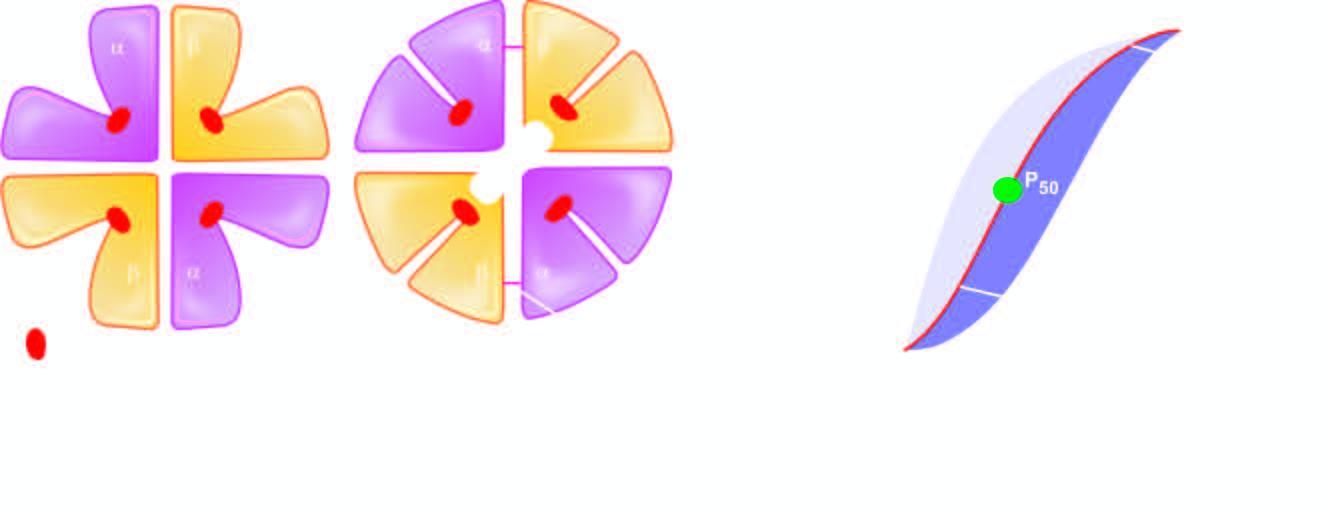re electron microscopy expelled?
Answer the question using a single word or phrase. No 